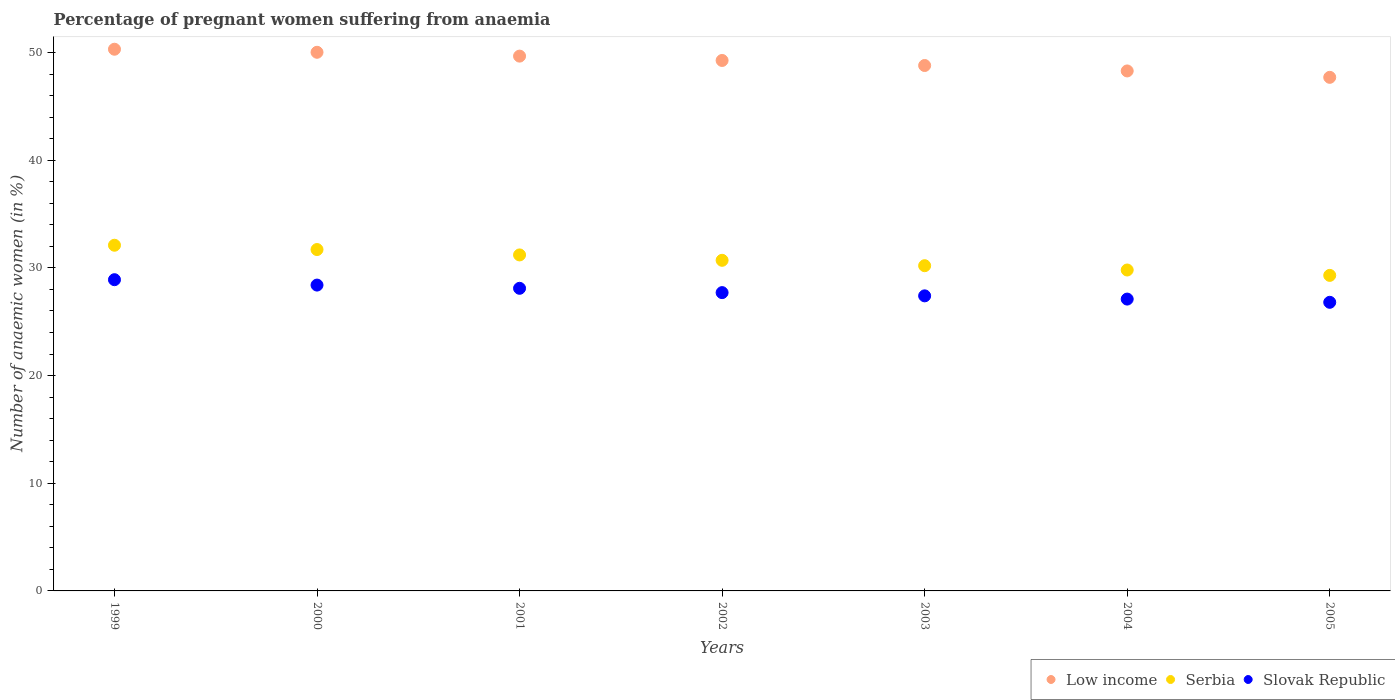How many different coloured dotlines are there?
Keep it short and to the point. 3. Is the number of dotlines equal to the number of legend labels?
Keep it short and to the point. Yes. What is the number of anaemic women in Low income in 2001?
Provide a short and direct response. 49.66. Across all years, what is the maximum number of anaemic women in Slovak Republic?
Ensure brevity in your answer.  28.9. Across all years, what is the minimum number of anaemic women in Slovak Republic?
Your response must be concise. 26.8. In which year was the number of anaemic women in Serbia minimum?
Your answer should be compact. 2005. What is the total number of anaemic women in Slovak Republic in the graph?
Keep it short and to the point. 194.4. What is the difference between the number of anaemic women in Serbia in 2000 and that in 2004?
Give a very brief answer. 1.9. What is the difference between the number of anaemic women in Slovak Republic in 2003 and the number of anaemic women in Serbia in 2005?
Your answer should be very brief. -1.9. What is the average number of anaemic women in Serbia per year?
Provide a short and direct response. 30.71. In the year 2003, what is the difference between the number of anaemic women in Slovak Republic and number of anaemic women in Low income?
Provide a succinct answer. -21.39. What is the ratio of the number of anaemic women in Low income in 2000 to that in 2003?
Provide a succinct answer. 1.03. What is the difference between the highest and the second highest number of anaemic women in Low income?
Make the answer very short. 0.28. What is the difference between the highest and the lowest number of anaemic women in Slovak Republic?
Give a very brief answer. 2.1. Is the sum of the number of anaemic women in Serbia in 2000 and 2001 greater than the maximum number of anaemic women in Low income across all years?
Your answer should be very brief. Yes. What is the difference between two consecutive major ticks on the Y-axis?
Give a very brief answer. 10. Are the values on the major ticks of Y-axis written in scientific E-notation?
Provide a short and direct response. No. What is the title of the graph?
Give a very brief answer. Percentage of pregnant women suffering from anaemia. Does "Marshall Islands" appear as one of the legend labels in the graph?
Make the answer very short. No. What is the label or title of the Y-axis?
Make the answer very short. Number of anaemic women (in %). What is the Number of anaemic women (in %) in Low income in 1999?
Ensure brevity in your answer.  50.3. What is the Number of anaemic women (in %) in Serbia in 1999?
Your answer should be very brief. 32.1. What is the Number of anaemic women (in %) in Slovak Republic in 1999?
Your answer should be compact. 28.9. What is the Number of anaemic women (in %) of Low income in 2000?
Make the answer very short. 50.02. What is the Number of anaemic women (in %) of Serbia in 2000?
Offer a terse response. 31.7. What is the Number of anaemic women (in %) in Slovak Republic in 2000?
Ensure brevity in your answer.  28.4. What is the Number of anaemic women (in %) in Low income in 2001?
Keep it short and to the point. 49.66. What is the Number of anaemic women (in %) of Serbia in 2001?
Ensure brevity in your answer.  31.2. What is the Number of anaemic women (in %) of Slovak Republic in 2001?
Provide a succinct answer. 28.1. What is the Number of anaemic women (in %) of Low income in 2002?
Make the answer very short. 49.26. What is the Number of anaemic women (in %) of Serbia in 2002?
Your answer should be very brief. 30.7. What is the Number of anaemic women (in %) of Slovak Republic in 2002?
Ensure brevity in your answer.  27.7. What is the Number of anaemic women (in %) of Low income in 2003?
Your answer should be very brief. 48.79. What is the Number of anaemic women (in %) of Serbia in 2003?
Your response must be concise. 30.2. What is the Number of anaemic women (in %) of Slovak Republic in 2003?
Provide a short and direct response. 27.4. What is the Number of anaemic women (in %) in Low income in 2004?
Make the answer very short. 48.28. What is the Number of anaemic women (in %) in Serbia in 2004?
Provide a short and direct response. 29.8. What is the Number of anaemic women (in %) of Slovak Republic in 2004?
Provide a short and direct response. 27.1. What is the Number of anaemic women (in %) in Low income in 2005?
Your response must be concise. 47.69. What is the Number of anaemic women (in %) in Serbia in 2005?
Make the answer very short. 29.3. What is the Number of anaemic women (in %) in Slovak Republic in 2005?
Your answer should be very brief. 26.8. Across all years, what is the maximum Number of anaemic women (in %) of Low income?
Your answer should be compact. 50.3. Across all years, what is the maximum Number of anaemic women (in %) of Serbia?
Your response must be concise. 32.1. Across all years, what is the maximum Number of anaemic women (in %) of Slovak Republic?
Give a very brief answer. 28.9. Across all years, what is the minimum Number of anaemic women (in %) in Low income?
Offer a very short reply. 47.69. Across all years, what is the minimum Number of anaemic women (in %) in Serbia?
Your answer should be compact. 29.3. Across all years, what is the minimum Number of anaemic women (in %) of Slovak Republic?
Your answer should be compact. 26.8. What is the total Number of anaemic women (in %) of Low income in the graph?
Your response must be concise. 344. What is the total Number of anaemic women (in %) in Serbia in the graph?
Give a very brief answer. 215. What is the total Number of anaemic women (in %) in Slovak Republic in the graph?
Your response must be concise. 194.4. What is the difference between the Number of anaemic women (in %) in Low income in 1999 and that in 2000?
Make the answer very short. 0.28. What is the difference between the Number of anaemic women (in %) of Serbia in 1999 and that in 2000?
Provide a succinct answer. 0.4. What is the difference between the Number of anaemic women (in %) in Slovak Republic in 1999 and that in 2000?
Provide a succinct answer. 0.5. What is the difference between the Number of anaemic women (in %) of Low income in 1999 and that in 2001?
Your answer should be very brief. 0.64. What is the difference between the Number of anaemic women (in %) of Low income in 1999 and that in 2002?
Keep it short and to the point. 1.04. What is the difference between the Number of anaemic women (in %) in Serbia in 1999 and that in 2002?
Provide a succinct answer. 1.4. What is the difference between the Number of anaemic women (in %) of Slovak Republic in 1999 and that in 2002?
Your answer should be compact. 1.2. What is the difference between the Number of anaemic women (in %) of Low income in 1999 and that in 2003?
Your response must be concise. 1.51. What is the difference between the Number of anaemic women (in %) of Low income in 1999 and that in 2004?
Make the answer very short. 2.02. What is the difference between the Number of anaemic women (in %) of Serbia in 1999 and that in 2004?
Offer a very short reply. 2.3. What is the difference between the Number of anaemic women (in %) of Slovak Republic in 1999 and that in 2004?
Provide a short and direct response. 1.8. What is the difference between the Number of anaemic women (in %) of Low income in 1999 and that in 2005?
Keep it short and to the point. 2.61. What is the difference between the Number of anaemic women (in %) in Serbia in 1999 and that in 2005?
Your response must be concise. 2.8. What is the difference between the Number of anaemic women (in %) of Low income in 2000 and that in 2001?
Keep it short and to the point. 0.36. What is the difference between the Number of anaemic women (in %) in Serbia in 2000 and that in 2001?
Keep it short and to the point. 0.5. What is the difference between the Number of anaemic women (in %) of Low income in 2000 and that in 2002?
Your response must be concise. 0.76. What is the difference between the Number of anaemic women (in %) of Serbia in 2000 and that in 2002?
Give a very brief answer. 1. What is the difference between the Number of anaemic women (in %) of Slovak Republic in 2000 and that in 2002?
Make the answer very short. 0.7. What is the difference between the Number of anaemic women (in %) of Low income in 2000 and that in 2003?
Your answer should be compact. 1.23. What is the difference between the Number of anaemic women (in %) in Serbia in 2000 and that in 2003?
Give a very brief answer. 1.5. What is the difference between the Number of anaemic women (in %) of Slovak Republic in 2000 and that in 2003?
Give a very brief answer. 1. What is the difference between the Number of anaemic women (in %) in Low income in 2000 and that in 2004?
Offer a very short reply. 1.73. What is the difference between the Number of anaemic women (in %) in Serbia in 2000 and that in 2004?
Your response must be concise. 1.9. What is the difference between the Number of anaemic women (in %) of Slovak Republic in 2000 and that in 2004?
Your response must be concise. 1.3. What is the difference between the Number of anaemic women (in %) in Low income in 2000 and that in 2005?
Provide a short and direct response. 2.33. What is the difference between the Number of anaemic women (in %) of Low income in 2001 and that in 2002?
Your response must be concise. 0.4. What is the difference between the Number of anaemic women (in %) in Slovak Republic in 2001 and that in 2002?
Keep it short and to the point. 0.4. What is the difference between the Number of anaemic women (in %) in Low income in 2001 and that in 2003?
Give a very brief answer. 0.87. What is the difference between the Number of anaemic women (in %) in Slovak Republic in 2001 and that in 2003?
Ensure brevity in your answer.  0.7. What is the difference between the Number of anaemic women (in %) of Low income in 2001 and that in 2004?
Your answer should be very brief. 1.38. What is the difference between the Number of anaemic women (in %) of Low income in 2001 and that in 2005?
Provide a succinct answer. 1.97. What is the difference between the Number of anaemic women (in %) of Serbia in 2001 and that in 2005?
Ensure brevity in your answer.  1.9. What is the difference between the Number of anaemic women (in %) of Slovak Republic in 2001 and that in 2005?
Ensure brevity in your answer.  1.3. What is the difference between the Number of anaemic women (in %) of Low income in 2002 and that in 2003?
Your answer should be very brief. 0.47. What is the difference between the Number of anaemic women (in %) in Slovak Republic in 2002 and that in 2003?
Offer a very short reply. 0.3. What is the difference between the Number of anaemic women (in %) in Low income in 2002 and that in 2004?
Offer a very short reply. 0.97. What is the difference between the Number of anaemic women (in %) of Slovak Republic in 2002 and that in 2004?
Ensure brevity in your answer.  0.6. What is the difference between the Number of anaemic women (in %) of Low income in 2002 and that in 2005?
Keep it short and to the point. 1.57. What is the difference between the Number of anaemic women (in %) of Low income in 2003 and that in 2004?
Ensure brevity in your answer.  0.5. What is the difference between the Number of anaemic women (in %) in Serbia in 2003 and that in 2004?
Your response must be concise. 0.4. What is the difference between the Number of anaemic women (in %) of Low income in 2003 and that in 2005?
Ensure brevity in your answer.  1.1. What is the difference between the Number of anaemic women (in %) of Serbia in 2003 and that in 2005?
Provide a short and direct response. 0.9. What is the difference between the Number of anaemic women (in %) of Slovak Republic in 2003 and that in 2005?
Your response must be concise. 0.6. What is the difference between the Number of anaemic women (in %) in Low income in 2004 and that in 2005?
Give a very brief answer. 0.59. What is the difference between the Number of anaemic women (in %) in Serbia in 2004 and that in 2005?
Keep it short and to the point. 0.5. What is the difference between the Number of anaemic women (in %) of Low income in 1999 and the Number of anaemic women (in %) of Serbia in 2000?
Ensure brevity in your answer.  18.6. What is the difference between the Number of anaemic women (in %) in Low income in 1999 and the Number of anaemic women (in %) in Slovak Republic in 2000?
Keep it short and to the point. 21.9. What is the difference between the Number of anaemic women (in %) in Serbia in 1999 and the Number of anaemic women (in %) in Slovak Republic in 2000?
Your response must be concise. 3.7. What is the difference between the Number of anaemic women (in %) of Low income in 1999 and the Number of anaemic women (in %) of Serbia in 2001?
Your answer should be very brief. 19.1. What is the difference between the Number of anaemic women (in %) of Low income in 1999 and the Number of anaemic women (in %) of Slovak Republic in 2001?
Provide a succinct answer. 22.2. What is the difference between the Number of anaemic women (in %) of Low income in 1999 and the Number of anaemic women (in %) of Serbia in 2002?
Offer a very short reply. 19.6. What is the difference between the Number of anaemic women (in %) in Low income in 1999 and the Number of anaemic women (in %) in Slovak Republic in 2002?
Your answer should be very brief. 22.6. What is the difference between the Number of anaemic women (in %) in Serbia in 1999 and the Number of anaemic women (in %) in Slovak Republic in 2002?
Your answer should be compact. 4.4. What is the difference between the Number of anaemic women (in %) of Low income in 1999 and the Number of anaemic women (in %) of Serbia in 2003?
Make the answer very short. 20.1. What is the difference between the Number of anaemic women (in %) of Low income in 1999 and the Number of anaemic women (in %) of Slovak Republic in 2003?
Your response must be concise. 22.9. What is the difference between the Number of anaemic women (in %) in Low income in 1999 and the Number of anaemic women (in %) in Serbia in 2004?
Your response must be concise. 20.5. What is the difference between the Number of anaemic women (in %) of Low income in 1999 and the Number of anaemic women (in %) of Slovak Republic in 2004?
Give a very brief answer. 23.2. What is the difference between the Number of anaemic women (in %) of Serbia in 1999 and the Number of anaemic women (in %) of Slovak Republic in 2004?
Ensure brevity in your answer.  5. What is the difference between the Number of anaemic women (in %) in Low income in 1999 and the Number of anaemic women (in %) in Serbia in 2005?
Give a very brief answer. 21. What is the difference between the Number of anaemic women (in %) of Low income in 1999 and the Number of anaemic women (in %) of Slovak Republic in 2005?
Your answer should be very brief. 23.5. What is the difference between the Number of anaemic women (in %) of Serbia in 1999 and the Number of anaemic women (in %) of Slovak Republic in 2005?
Ensure brevity in your answer.  5.3. What is the difference between the Number of anaemic women (in %) of Low income in 2000 and the Number of anaemic women (in %) of Serbia in 2001?
Keep it short and to the point. 18.82. What is the difference between the Number of anaemic women (in %) in Low income in 2000 and the Number of anaemic women (in %) in Slovak Republic in 2001?
Offer a terse response. 21.92. What is the difference between the Number of anaemic women (in %) of Low income in 2000 and the Number of anaemic women (in %) of Serbia in 2002?
Your response must be concise. 19.32. What is the difference between the Number of anaemic women (in %) of Low income in 2000 and the Number of anaemic women (in %) of Slovak Republic in 2002?
Your answer should be compact. 22.32. What is the difference between the Number of anaemic women (in %) in Serbia in 2000 and the Number of anaemic women (in %) in Slovak Republic in 2002?
Offer a terse response. 4. What is the difference between the Number of anaemic women (in %) in Low income in 2000 and the Number of anaemic women (in %) in Serbia in 2003?
Provide a short and direct response. 19.82. What is the difference between the Number of anaemic women (in %) of Low income in 2000 and the Number of anaemic women (in %) of Slovak Republic in 2003?
Provide a short and direct response. 22.62. What is the difference between the Number of anaemic women (in %) of Serbia in 2000 and the Number of anaemic women (in %) of Slovak Republic in 2003?
Make the answer very short. 4.3. What is the difference between the Number of anaemic women (in %) of Low income in 2000 and the Number of anaemic women (in %) of Serbia in 2004?
Provide a succinct answer. 20.22. What is the difference between the Number of anaemic women (in %) of Low income in 2000 and the Number of anaemic women (in %) of Slovak Republic in 2004?
Provide a short and direct response. 22.92. What is the difference between the Number of anaemic women (in %) in Low income in 2000 and the Number of anaemic women (in %) in Serbia in 2005?
Give a very brief answer. 20.72. What is the difference between the Number of anaemic women (in %) of Low income in 2000 and the Number of anaemic women (in %) of Slovak Republic in 2005?
Offer a terse response. 23.22. What is the difference between the Number of anaemic women (in %) of Serbia in 2000 and the Number of anaemic women (in %) of Slovak Republic in 2005?
Provide a short and direct response. 4.9. What is the difference between the Number of anaemic women (in %) in Low income in 2001 and the Number of anaemic women (in %) in Serbia in 2002?
Keep it short and to the point. 18.96. What is the difference between the Number of anaemic women (in %) of Low income in 2001 and the Number of anaemic women (in %) of Slovak Republic in 2002?
Your answer should be very brief. 21.96. What is the difference between the Number of anaemic women (in %) of Serbia in 2001 and the Number of anaemic women (in %) of Slovak Republic in 2002?
Ensure brevity in your answer.  3.5. What is the difference between the Number of anaemic women (in %) in Low income in 2001 and the Number of anaemic women (in %) in Serbia in 2003?
Make the answer very short. 19.46. What is the difference between the Number of anaemic women (in %) in Low income in 2001 and the Number of anaemic women (in %) in Slovak Republic in 2003?
Your answer should be compact. 22.26. What is the difference between the Number of anaemic women (in %) in Serbia in 2001 and the Number of anaemic women (in %) in Slovak Republic in 2003?
Your answer should be very brief. 3.8. What is the difference between the Number of anaemic women (in %) of Low income in 2001 and the Number of anaemic women (in %) of Serbia in 2004?
Provide a short and direct response. 19.86. What is the difference between the Number of anaemic women (in %) in Low income in 2001 and the Number of anaemic women (in %) in Slovak Republic in 2004?
Keep it short and to the point. 22.56. What is the difference between the Number of anaemic women (in %) of Low income in 2001 and the Number of anaemic women (in %) of Serbia in 2005?
Your answer should be very brief. 20.36. What is the difference between the Number of anaemic women (in %) of Low income in 2001 and the Number of anaemic women (in %) of Slovak Republic in 2005?
Offer a very short reply. 22.86. What is the difference between the Number of anaemic women (in %) in Low income in 2002 and the Number of anaemic women (in %) in Serbia in 2003?
Ensure brevity in your answer.  19.06. What is the difference between the Number of anaemic women (in %) in Low income in 2002 and the Number of anaemic women (in %) in Slovak Republic in 2003?
Your answer should be compact. 21.86. What is the difference between the Number of anaemic women (in %) of Serbia in 2002 and the Number of anaemic women (in %) of Slovak Republic in 2003?
Your response must be concise. 3.3. What is the difference between the Number of anaemic women (in %) in Low income in 2002 and the Number of anaemic women (in %) in Serbia in 2004?
Offer a terse response. 19.46. What is the difference between the Number of anaemic women (in %) in Low income in 2002 and the Number of anaemic women (in %) in Slovak Republic in 2004?
Give a very brief answer. 22.16. What is the difference between the Number of anaemic women (in %) in Serbia in 2002 and the Number of anaemic women (in %) in Slovak Republic in 2004?
Your response must be concise. 3.6. What is the difference between the Number of anaemic women (in %) of Low income in 2002 and the Number of anaemic women (in %) of Serbia in 2005?
Give a very brief answer. 19.96. What is the difference between the Number of anaemic women (in %) of Low income in 2002 and the Number of anaemic women (in %) of Slovak Republic in 2005?
Your response must be concise. 22.46. What is the difference between the Number of anaemic women (in %) of Serbia in 2002 and the Number of anaemic women (in %) of Slovak Republic in 2005?
Your response must be concise. 3.9. What is the difference between the Number of anaemic women (in %) of Low income in 2003 and the Number of anaemic women (in %) of Serbia in 2004?
Provide a short and direct response. 18.99. What is the difference between the Number of anaemic women (in %) of Low income in 2003 and the Number of anaemic women (in %) of Slovak Republic in 2004?
Provide a succinct answer. 21.69. What is the difference between the Number of anaemic women (in %) in Serbia in 2003 and the Number of anaemic women (in %) in Slovak Republic in 2004?
Ensure brevity in your answer.  3.1. What is the difference between the Number of anaemic women (in %) in Low income in 2003 and the Number of anaemic women (in %) in Serbia in 2005?
Your answer should be compact. 19.49. What is the difference between the Number of anaemic women (in %) of Low income in 2003 and the Number of anaemic women (in %) of Slovak Republic in 2005?
Give a very brief answer. 21.99. What is the difference between the Number of anaemic women (in %) in Low income in 2004 and the Number of anaemic women (in %) in Serbia in 2005?
Offer a terse response. 18.98. What is the difference between the Number of anaemic women (in %) in Low income in 2004 and the Number of anaemic women (in %) in Slovak Republic in 2005?
Offer a very short reply. 21.48. What is the average Number of anaemic women (in %) in Low income per year?
Offer a terse response. 49.14. What is the average Number of anaemic women (in %) in Serbia per year?
Keep it short and to the point. 30.71. What is the average Number of anaemic women (in %) of Slovak Republic per year?
Keep it short and to the point. 27.77. In the year 1999, what is the difference between the Number of anaemic women (in %) in Low income and Number of anaemic women (in %) in Serbia?
Your answer should be very brief. 18.2. In the year 1999, what is the difference between the Number of anaemic women (in %) in Low income and Number of anaemic women (in %) in Slovak Republic?
Provide a short and direct response. 21.4. In the year 2000, what is the difference between the Number of anaemic women (in %) in Low income and Number of anaemic women (in %) in Serbia?
Offer a terse response. 18.32. In the year 2000, what is the difference between the Number of anaemic women (in %) of Low income and Number of anaemic women (in %) of Slovak Republic?
Your response must be concise. 21.62. In the year 2001, what is the difference between the Number of anaemic women (in %) in Low income and Number of anaemic women (in %) in Serbia?
Your answer should be very brief. 18.46. In the year 2001, what is the difference between the Number of anaemic women (in %) of Low income and Number of anaemic women (in %) of Slovak Republic?
Keep it short and to the point. 21.56. In the year 2001, what is the difference between the Number of anaemic women (in %) of Serbia and Number of anaemic women (in %) of Slovak Republic?
Provide a short and direct response. 3.1. In the year 2002, what is the difference between the Number of anaemic women (in %) in Low income and Number of anaemic women (in %) in Serbia?
Make the answer very short. 18.56. In the year 2002, what is the difference between the Number of anaemic women (in %) of Low income and Number of anaemic women (in %) of Slovak Republic?
Keep it short and to the point. 21.56. In the year 2002, what is the difference between the Number of anaemic women (in %) in Serbia and Number of anaemic women (in %) in Slovak Republic?
Your response must be concise. 3. In the year 2003, what is the difference between the Number of anaemic women (in %) in Low income and Number of anaemic women (in %) in Serbia?
Ensure brevity in your answer.  18.59. In the year 2003, what is the difference between the Number of anaemic women (in %) in Low income and Number of anaemic women (in %) in Slovak Republic?
Keep it short and to the point. 21.39. In the year 2004, what is the difference between the Number of anaemic women (in %) in Low income and Number of anaemic women (in %) in Serbia?
Give a very brief answer. 18.48. In the year 2004, what is the difference between the Number of anaemic women (in %) of Low income and Number of anaemic women (in %) of Slovak Republic?
Your response must be concise. 21.18. In the year 2004, what is the difference between the Number of anaemic women (in %) of Serbia and Number of anaemic women (in %) of Slovak Republic?
Offer a very short reply. 2.7. In the year 2005, what is the difference between the Number of anaemic women (in %) in Low income and Number of anaemic women (in %) in Serbia?
Provide a succinct answer. 18.39. In the year 2005, what is the difference between the Number of anaemic women (in %) of Low income and Number of anaemic women (in %) of Slovak Republic?
Your answer should be very brief. 20.89. What is the ratio of the Number of anaemic women (in %) in Serbia in 1999 to that in 2000?
Your answer should be compact. 1.01. What is the ratio of the Number of anaemic women (in %) of Slovak Republic in 1999 to that in 2000?
Provide a succinct answer. 1.02. What is the ratio of the Number of anaemic women (in %) of Low income in 1999 to that in 2001?
Ensure brevity in your answer.  1.01. What is the ratio of the Number of anaemic women (in %) in Serbia in 1999 to that in 2001?
Offer a very short reply. 1.03. What is the ratio of the Number of anaemic women (in %) of Slovak Republic in 1999 to that in 2001?
Provide a short and direct response. 1.03. What is the ratio of the Number of anaemic women (in %) in Low income in 1999 to that in 2002?
Ensure brevity in your answer.  1.02. What is the ratio of the Number of anaemic women (in %) of Serbia in 1999 to that in 2002?
Give a very brief answer. 1.05. What is the ratio of the Number of anaemic women (in %) in Slovak Republic in 1999 to that in 2002?
Offer a terse response. 1.04. What is the ratio of the Number of anaemic women (in %) in Low income in 1999 to that in 2003?
Make the answer very short. 1.03. What is the ratio of the Number of anaemic women (in %) in Serbia in 1999 to that in 2003?
Offer a terse response. 1.06. What is the ratio of the Number of anaemic women (in %) in Slovak Republic in 1999 to that in 2003?
Offer a very short reply. 1.05. What is the ratio of the Number of anaemic women (in %) in Low income in 1999 to that in 2004?
Your response must be concise. 1.04. What is the ratio of the Number of anaemic women (in %) of Serbia in 1999 to that in 2004?
Keep it short and to the point. 1.08. What is the ratio of the Number of anaemic women (in %) of Slovak Republic in 1999 to that in 2004?
Your answer should be compact. 1.07. What is the ratio of the Number of anaemic women (in %) in Low income in 1999 to that in 2005?
Offer a terse response. 1.05. What is the ratio of the Number of anaemic women (in %) of Serbia in 1999 to that in 2005?
Your response must be concise. 1.1. What is the ratio of the Number of anaemic women (in %) in Slovak Republic in 1999 to that in 2005?
Keep it short and to the point. 1.08. What is the ratio of the Number of anaemic women (in %) in Low income in 2000 to that in 2001?
Your answer should be compact. 1.01. What is the ratio of the Number of anaemic women (in %) of Slovak Republic in 2000 to that in 2001?
Ensure brevity in your answer.  1.01. What is the ratio of the Number of anaemic women (in %) of Low income in 2000 to that in 2002?
Keep it short and to the point. 1.02. What is the ratio of the Number of anaemic women (in %) in Serbia in 2000 to that in 2002?
Your answer should be very brief. 1.03. What is the ratio of the Number of anaemic women (in %) of Slovak Republic in 2000 to that in 2002?
Keep it short and to the point. 1.03. What is the ratio of the Number of anaemic women (in %) of Low income in 2000 to that in 2003?
Provide a short and direct response. 1.03. What is the ratio of the Number of anaemic women (in %) in Serbia in 2000 to that in 2003?
Keep it short and to the point. 1.05. What is the ratio of the Number of anaemic women (in %) of Slovak Republic in 2000 to that in 2003?
Ensure brevity in your answer.  1.04. What is the ratio of the Number of anaemic women (in %) of Low income in 2000 to that in 2004?
Your response must be concise. 1.04. What is the ratio of the Number of anaemic women (in %) of Serbia in 2000 to that in 2004?
Your answer should be compact. 1.06. What is the ratio of the Number of anaemic women (in %) of Slovak Republic in 2000 to that in 2004?
Offer a very short reply. 1.05. What is the ratio of the Number of anaemic women (in %) of Low income in 2000 to that in 2005?
Provide a short and direct response. 1.05. What is the ratio of the Number of anaemic women (in %) in Serbia in 2000 to that in 2005?
Your response must be concise. 1.08. What is the ratio of the Number of anaemic women (in %) in Slovak Republic in 2000 to that in 2005?
Provide a short and direct response. 1.06. What is the ratio of the Number of anaemic women (in %) in Low income in 2001 to that in 2002?
Ensure brevity in your answer.  1.01. What is the ratio of the Number of anaemic women (in %) of Serbia in 2001 to that in 2002?
Give a very brief answer. 1.02. What is the ratio of the Number of anaemic women (in %) in Slovak Republic in 2001 to that in 2002?
Your answer should be very brief. 1.01. What is the ratio of the Number of anaemic women (in %) in Low income in 2001 to that in 2003?
Offer a very short reply. 1.02. What is the ratio of the Number of anaemic women (in %) of Serbia in 2001 to that in 2003?
Offer a very short reply. 1.03. What is the ratio of the Number of anaemic women (in %) of Slovak Republic in 2001 to that in 2003?
Your answer should be compact. 1.03. What is the ratio of the Number of anaemic women (in %) of Low income in 2001 to that in 2004?
Your response must be concise. 1.03. What is the ratio of the Number of anaemic women (in %) in Serbia in 2001 to that in 2004?
Ensure brevity in your answer.  1.05. What is the ratio of the Number of anaemic women (in %) of Slovak Republic in 2001 to that in 2004?
Your answer should be compact. 1.04. What is the ratio of the Number of anaemic women (in %) of Low income in 2001 to that in 2005?
Provide a succinct answer. 1.04. What is the ratio of the Number of anaemic women (in %) in Serbia in 2001 to that in 2005?
Your answer should be very brief. 1.06. What is the ratio of the Number of anaemic women (in %) of Slovak Republic in 2001 to that in 2005?
Offer a terse response. 1.05. What is the ratio of the Number of anaemic women (in %) in Low income in 2002 to that in 2003?
Your answer should be very brief. 1.01. What is the ratio of the Number of anaemic women (in %) in Serbia in 2002 to that in 2003?
Provide a short and direct response. 1.02. What is the ratio of the Number of anaemic women (in %) in Slovak Republic in 2002 to that in 2003?
Provide a short and direct response. 1.01. What is the ratio of the Number of anaemic women (in %) of Low income in 2002 to that in 2004?
Offer a very short reply. 1.02. What is the ratio of the Number of anaemic women (in %) in Serbia in 2002 to that in 2004?
Ensure brevity in your answer.  1.03. What is the ratio of the Number of anaemic women (in %) in Slovak Republic in 2002 to that in 2004?
Your answer should be very brief. 1.02. What is the ratio of the Number of anaemic women (in %) in Low income in 2002 to that in 2005?
Keep it short and to the point. 1.03. What is the ratio of the Number of anaemic women (in %) in Serbia in 2002 to that in 2005?
Your answer should be compact. 1.05. What is the ratio of the Number of anaemic women (in %) in Slovak Republic in 2002 to that in 2005?
Give a very brief answer. 1.03. What is the ratio of the Number of anaemic women (in %) of Low income in 2003 to that in 2004?
Your answer should be very brief. 1.01. What is the ratio of the Number of anaemic women (in %) in Serbia in 2003 to that in 2004?
Provide a short and direct response. 1.01. What is the ratio of the Number of anaemic women (in %) in Slovak Republic in 2003 to that in 2004?
Ensure brevity in your answer.  1.01. What is the ratio of the Number of anaemic women (in %) of Low income in 2003 to that in 2005?
Offer a terse response. 1.02. What is the ratio of the Number of anaemic women (in %) in Serbia in 2003 to that in 2005?
Keep it short and to the point. 1.03. What is the ratio of the Number of anaemic women (in %) of Slovak Republic in 2003 to that in 2005?
Your answer should be compact. 1.02. What is the ratio of the Number of anaemic women (in %) of Low income in 2004 to that in 2005?
Offer a terse response. 1.01. What is the ratio of the Number of anaemic women (in %) in Serbia in 2004 to that in 2005?
Offer a very short reply. 1.02. What is the ratio of the Number of anaemic women (in %) of Slovak Republic in 2004 to that in 2005?
Provide a succinct answer. 1.01. What is the difference between the highest and the second highest Number of anaemic women (in %) in Low income?
Your answer should be compact. 0.28. What is the difference between the highest and the second highest Number of anaemic women (in %) of Slovak Republic?
Provide a short and direct response. 0.5. What is the difference between the highest and the lowest Number of anaemic women (in %) in Low income?
Make the answer very short. 2.61. What is the difference between the highest and the lowest Number of anaemic women (in %) of Serbia?
Keep it short and to the point. 2.8. 